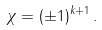<formula> <loc_0><loc_0><loc_500><loc_500>\chi = ( \pm 1 ) ^ { k + 1 } \, .</formula> 